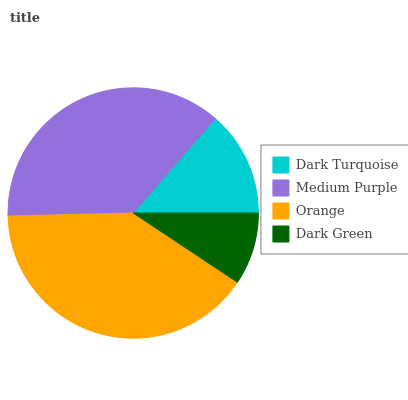Is Dark Green the minimum?
Answer yes or no. Yes. Is Orange the maximum?
Answer yes or no. Yes. Is Medium Purple the minimum?
Answer yes or no. No. Is Medium Purple the maximum?
Answer yes or no. No. Is Medium Purple greater than Dark Turquoise?
Answer yes or no. Yes. Is Dark Turquoise less than Medium Purple?
Answer yes or no. Yes. Is Dark Turquoise greater than Medium Purple?
Answer yes or no. No. Is Medium Purple less than Dark Turquoise?
Answer yes or no. No. Is Medium Purple the high median?
Answer yes or no. Yes. Is Dark Turquoise the low median?
Answer yes or no. Yes. Is Orange the high median?
Answer yes or no. No. Is Orange the low median?
Answer yes or no. No. 